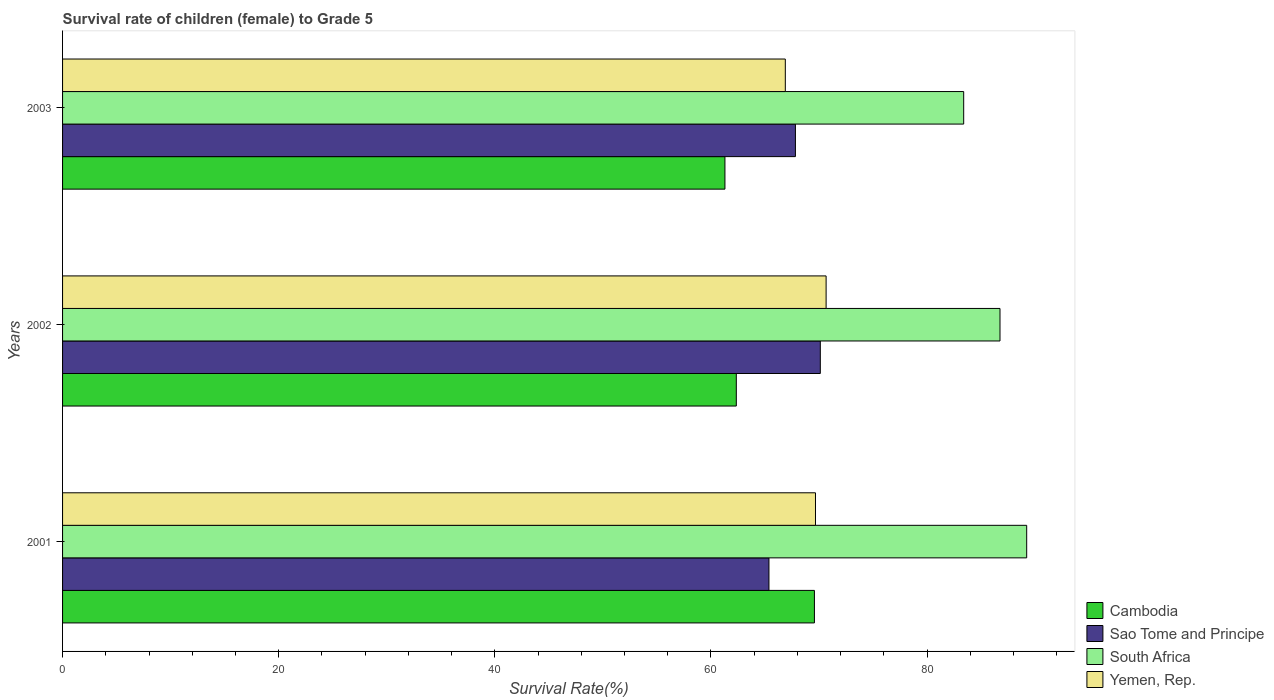How many different coloured bars are there?
Offer a terse response. 4. What is the label of the 1st group of bars from the top?
Provide a short and direct response. 2003. What is the survival rate of female children to grade 5 in Sao Tome and Principe in 2002?
Your answer should be compact. 70.12. Across all years, what is the maximum survival rate of female children to grade 5 in Sao Tome and Principe?
Offer a very short reply. 70.12. Across all years, what is the minimum survival rate of female children to grade 5 in South Africa?
Your response must be concise. 83.39. What is the total survival rate of female children to grade 5 in Sao Tome and Principe in the graph?
Give a very brief answer. 203.31. What is the difference between the survival rate of female children to grade 5 in Sao Tome and Principe in 2001 and that in 2002?
Give a very brief answer. -4.75. What is the difference between the survival rate of female children to grade 5 in South Africa in 2001 and the survival rate of female children to grade 5 in Sao Tome and Principe in 2002?
Your response must be concise. 19.1. What is the average survival rate of female children to grade 5 in Cambodia per year?
Provide a succinct answer. 64.41. In the year 2003, what is the difference between the survival rate of female children to grade 5 in Cambodia and survival rate of female children to grade 5 in Yemen, Rep.?
Ensure brevity in your answer.  -5.59. What is the ratio of the survival rate of female children to grade 5 in Yemen, Rep. in 2001 to that in 2003?
Keep it short and to the point. 1.04. What is the difference between the highest and the second highest survival rate of female children to grade 5 in South Africa?
Ensure brevity in your answer.  2.47. What is the difference between the highest and the lowest survival rate of female children to grade 5 in Yemen, Rep.?
Your answer should be very brief. 3.78. In how many years, is the survival rate of female children to grade 5 in Yemen, Rep. greater than the average survival rate of female children to grade 5 in Yemen, Rep. taken over all years?
Provide a succinct answer. 2. Is it the case that in every year, the sum of the survival rate of female children to grade 5 in Sao Tome and Principe and survival rate of female children to grade 5 in South Africa is greater than the sum of survival rate of female children to grade 5 in Yemen, Rep. and survival rate of female children to grade 5 in Cambodia?
Give a very brief answer. Yes. What does the 3rd bar from the top in 2001 represents?
Keep it short and to the point. Sao Tome and Principe. What does the 2nd bar from the bottom in 2003 represents?
Keep it short and to the point. Sao Tome and Principe. Is it the case that in every year, the sum of the survival rate of female children to grade 5 in Sao Tome and Principe and survival rate of female children to grade 5 in Yemen, Rep. is greater than the survival rate of female children to grade 5 in Cambodia?
Give a very brief answer. Yes. Are all the bars in the graph horizontal?
Offer a terse response. Yes. Are the values on the major ticks of X-axis written in scientific E-notation?
Offer a terse response. No. Does the graph contain grids?
Your answer should be very brief. No. Where does the legend appear in the graph?
Provide a succinct answer. Bottom right. How many legend labels are there?
Offer a terse response. 4. How are the legend labels stacked?
Your response must be concise. Vertical. What is the title of the graph?
Ensure brevity in your answer.  Survival rate of children (female) to Grade 5. Does "Poland" appear as one of the legend labels in the graph?
Provide a short and direct response. No. What is the label or title of the X-axis?
Provide a succinct answer. Survival Rate(%). What is the Survival Rate(%) of Cambodia in 2001?
Your response must be concise. 69.58. What is the Survival Rate(%) of Sao Tome and Principe in 2001?
Keep it short and to the point. 65.37. What is the Survival Rate(%) in South Africa in 2001?
Provide a short and direct response. 89.22. What is the Survival Rate(%) in Yemen, Rep. in 2001?
Your response must be concise. 69.67. What is the Survival Rate(%) in Cambodia in 2002?
Provide a succinct answer. 62.35. What is the Survival Rate(%) of Sao Tome and Principe in 2002?
Your response must be concise. 70.12. What is the Survival Rate(%) in South Africa in 2002?
Offer a very short reply. 86.75. What is the Survival Rate(%) of Yemen, Rep. in 2002?
Offer a very short reply. 70.66. What is the Survival Rate(%) in Cambodia in 2003?
Offer a terse response. 61.29. What is the Survival Rate(%) of Sao Tome and Principe in 2003?
Ensure brevity in your answer.  67.82. What is the Survival Rate(%) of South Africa in 2003?
Give a very brief answer. 83.39. What is the Survival Rate(%) of Yemen, Rep. in 2003?
Your answer should be very brief. 66.88. Across all years, what is the maximum Survival Rate(%) in Cambodia?
Give a very brief answer. 69.58. Across all years, what is the maximum Survival Rate(%) in Sao Tome and Principe?
Make the answer very short. 70.12. Across all years, what is the maximum Survival Rate(%) in South Africa?
Your response must be concise. 89.22. Across all years, what is the maximum Survival Rate(%) in Yemen, Rep.?
Your answer should be compact. 70.66. Across all years, what is the minimum Survival Rate(%) of Cambodia?
Provide a short and direct response. 61.29. Across all years, what is the minimum Survival Rate(%) of Sao Tome and Principe?
Your answer should be very brief. 65.37. Across all years, what is the minimum Survival Rate(%) in South Africa?
Give a very brief answer. 83.39. Across all years, what is the minimum Survival Rate(%) in Yemen, Rep.?
Provide a succinct answer. 66.88. What is the total Survival Rate(%) of Cambodia in the graph?
Your answer should be compact. 193.22. What is the total Survival Rate(%) of Sao Tome and Principe in the graph?
Offer a very short reply. 203.31. What is the total Survival Rate(%) in South Africa in the graph?
Your answer should be very brief. 259.36. What is the total Survival Rate(%) in Yemen, Rep. in the graph?
Give a very brief answer. 207.21. What is the difference between the Survival Rate(%) in Cambodia in 2001 and that in 2002?
Your answer should be compact. 7.23. What is the difference between the Survival Rate(%) in Sao Tome and Principe in 2001 and that in 2002?
Provide a short and direct response. -4.75. What is the difference between the Survival Rate(%) of South Africa in 2001 and that in 2002?
Make the answer very short. 2.47. What is the difference between the Survival Rate(%) in Yemen, Rep. in 2001 and that in 2002?
Keep it short and to the point. -0.98. What is the difference between the Survival Rate(%) in Cambodia in 2001 and that in 2003?
Make the answer very short. 8.28. What is the difference between the Survival Rate(%) in Sao Tome and Principe in 2001 and that in 2003?
Your answer should be very brief. -2.45. What is the difference between the Survival Rate(%) of South Africa in 2001 and that in 2003?
Offer a very short reply. 5.83. What is the difference between the Survival Rate(%) of Yemen, Rep. in 2001 and that in 2003?
Provide a short and direct response. 2.79. What is the difference between the Survival Rate(%) in Cambodia in 2002 and that in 2003?
Keep it short and to the point. 1.05. What is the difference between the Survival Rate(%) in Sao Tome and Principe in 2002 and that in 2003?
Provide a succinct answer. 2.3. What is the difference between the Survival Rate(%) of South Africa in 2002 and that in 2003?
Your answer should be very brief. 3.36. What is the difference between the Survival Rate(%) of Yemen, Rep. in 2002 and that in 2003?
Give a very brief answer. 3.78. What is the difference between the Survival Rate(%) of Cambodia in 2001 and the Survival Rate(%) of Sao Tome and Principe in 2002?
Keep it short and to the point. -0.55. What is the difference between the Survival Rate(%) in Cambodia in 2001 and the Survival Rate(%) in South Africa in 2002?
Offer a terse response. -17.17. What is the difference between the Survival Rate(%) of Cambodia in 2001 and the Survival Rate(%) of Yemen, Rep. in 2002?
Make the answer very short. -1.08. What is the difference between the Survival Rate(%) of Sao Tome and Principe in 2001 and the Survival Rate(%) of South Africa in 2002?
Ensure brevity in your answer.  -21.38. What is the difference between the Survival Rate(%) in Sao Tome and Principe in 2001 and the Survival Rate(%) in Yemen, Rep. in 2002?
Keep it short and to the point. -5.29. What is the difference between the Survival Rate(%) of South Africa in 2001 and the Survival Rate(%) of Yemen, Rep. in 2002?
Offer a terse response. 18.56. What is the difference between the Survival Rate(%) in Cambodia in 2001 and the Survival Rate(%) in Sao Tome and Principe in 2003?
Your answer should be very brief. 1.76. What is the difference between the Survival Rate(%) in Cambodia in 2001 and the Survival Rate(%) in South Africa in 2003?
Offer a terse response. -13.81. What is the difference between the Survival Rate(%) in Cambodia in 2001 and the Survival Rate(%) in Yemen, Rep. in 2003?
Keep it short and to the point. 2.69. What is the difference between the Survival Rate(%) in Sao Tome and Principe in 2001 and the Survival Rate(%) in South Africa in 2003?
Provide a short and direct response. -18.02. What is the difference between the Survival Rate(%) in Sao Tome and Principe in 2001 and the Survival Rate(%) in Yemen, Rep. in 2003?
Make the answer very short. -1.51. What is the difference between the Survival Rate(%) of South Africa in 2001 and the Survival Rate(%) of Yemen, Rep. in 2003?
Offer a terse response. 22.34. What is the difference between the Survival Rate(%) in Cambodia in 2002 and the Survival Rate(%) in Sao Tome and Principe in 2003?
Offer a terse response. -5.47. What is the difference between the Survival Rate(%) in Cambodia in 2002 and the Survival Rate(%) in South Africa in 2003?
Give a very brief answer. -21.04. What is the difference between the Survival Rate(%) of Cambodia in 2002 and the Survival Rate(%) of Yemen, Rep. in 2003?
Your answer should be very brief. -4.53. What is the difference between the Survival Rate(%) in Sao Tome and Principe in 2002 and the Survival Rate(%) in South Africa in 2003?
Offer a very short reply. -13.27. What is the difference between the Survival Rate(%) in Sao Tome and Principe in 2002 and the Survival Rate(%) in Yemen, Rep. in 2003?
Offer a very short reply. 3.24. What is the difference between the Survival Rate(%) in South Africa in 2002 and the Survival Rate(%) in Yemen, Rep. in 2003?
Provide a short and direct response. 19.87. What is the average Survival Rate(%) of Cambodia per year?
Keep it short and to the point. 64.41. What is the average Survival Rate(%) in Sao Tome and Principe per year?
Keep it short and to the point. 67.77. What is the average Survival Rate(%) of South Africa per year?
Your response must be concise. 86.45. What is the average Survival Rate(%) in Yemen, Rep. per year?
Your response must be concise. 69.07. In the year 2001, what is the difference between the Survival Rate(%) of Cambodia and Survival Rate(%) of Sao Tome and Principe?
Provide a succinct answer. 4.21. In the year 2001, what is the difference between the Survival Rate(%) of Cambodia and Survival Rate(%) of South Africa?
Give a very brief answer. -19.64. In the year 2001, what is the difference between the Survival Rate(%) in Cambodia and Survival Rate(%) in Yemen, Rep.?
Keep it short and to the point. -0.1. In the year 2001, what is the difference between the Survival Rate(%) in Sao Tome and Principe and Survival Rate(%) in South Africa?
Give a very brief answer. -23.85. In the year 2001, what is the difference between the Survival Rate(%) in Sao Tome and Principe and Survival Rate(%) in Yemen, Rep.?
Keep it short and to the point. -4.31. In the year 2001, what is the difference between the Survival Rate(%) in South Africa and Survival Rate(%) in Yemen, Rep.?
Make the answer very short. 19.55. In the year 2002, what is the difference between the Survival Rate(%) of Cambodia and Survival Rate(%) of Sao Tome and Principe?
Offer a terse response. -7.77. In the year 2002, what is the difference between the Survival Rate(%) of Cambodia and Survival Rate(%) of South Africa?
Ensure brevity in your answer.  -24.4. In the year 2002, what is the difference between the Survival Rate(%) in Cambodia and Survival Rate(%) in Yemen, Rep.?
Provide a short and direct response. -8.31. In the year 2002, what is the difference between the Survival Rate(%) of Sao Tome and Principe and Survival Rate(%) of South Africa?
Your answer should be compact. -16.63. In the year 2002, what is the difference between the Survival Rate(%) in Sao Tome and Principe and Survival Rate(%) in Yemen, Rep.?
Make the answer very short. -0.54. In the year 2002, what is the difference between the Survival Rate(%) in South Africa and Survival Rate(%) in Yemen, Rep.?
Your answer should be very brief. 16.09. In the year 2003, what is the difference between the Survival Rate(%) of Cambodia and Survival Rate(%) of Sao Tome and Principe?
Give a very brief answer. -6.52. In the year 2003, what is the difference between the Survival Rate(%) of Cambodia and Survival Rate(%) of South Africa?
Make the answer very short. -22.09. In the year 2003, what is the difference between the Survival Rate(%) of Cambodia and Survival Rate(%) of Yemen, Rep.?
Your response must be concise. -5.59. In the year 2003, what is the difference between the Survival Rate(%) of Sao Tome and Principe and Survival Rate(%) of South Africa?
Provide a short and direct response. -15.57. In the year 2003, what is the difference between the Survival Rate(%) in Sao Tome and Principe and Survival Rate(%) in Yemen, Rep.?
Offer a very short reply. 0.94. In the year 2003, what is the difference between the Survival Rate(%) in South Africa and Survival Rate(%) in Yemen, Rep.?
Make the answer very short. 16.51. What is the ratio of the Survival Rate(%) in Cambodia in 2001 to that in 2002?
Provide a succinct answer. 1.12. What is the ratio of the Survival Rate(%) of Sao Tome and Principe in 2001 to that in 2002?
Ensure brevity in your answer.  0.93. What is the ratio of the Survival Rate(%) in South Africa in 2001 to that in 2002?
Ensure brevity in your answer.  1.03. What is the ratio of the Survival Rate(%) in Yemen, Rep. in 2001 to that in 2002?
Provide a short and direct response. 0.99. What is the ratio of the Survival Rate(%) of Cambodia in 2001 to that in 2003?
Make the answer very short. 1.14. What is the ratio of the Survival Rate(%) of Sao Tome and Principe in 2001 to that in 2003?
Ensure brevity in your answer.  0.96. What is the ratio of the Survival Rate(%) in South Africa in 2001 to that in 2003?
Your answer should be compact. 1.07. What is the ratio of the Survival Rate(%) of Yemen, Rep. in 2001 to that in 2003?
Your response must be concise. 1.04. What is the ratio of the Survival Rate(%) of Cambodia in 2002 to that in 2003?
Provide a succinct answer. 1.02. What is the ratio of the Survival Rate(%) in Sao Tome and Principe in 2002 to that in 2003?
Make the answer very short. 1.03. What is the ratio of the Survival Rate(%) in South Africa in 2002 to that in 2003?
Offer a terse response. 1.04. What is the ratio of the Survival Rate(%) of Yemen, Rep. in 2002 to that in 2003?
Provide a short and direct response. 1.06. What is the difference between the highest and the second highest Survival Rate(%) in Cambodia?
Provide a succinct answer. 7.23. What is the difference between the highest and the second highest Survival Rate(%) in Sao Tome and Principe?
Your response must be concise. 2.3. What is the difference between the highest and the second highest Survival Rate(%) in South Africa?
Offer a terse response. 2.47. What is the difference between the highest and the second highest Survival Rate(%) of Yemen, Rep.?
Keep it short and to the point. 0.98. What is the difference between the highest and the lowest Survival Rate(%) in Cambodia?
Keep it short and to the point. 8.28. What is the difference between the highest and the lowest Survival Rate(%) in Sao Tome and Principe?
Keep it short and to the point. 4.75. What is the difference between the highest and the lowest Survival Rate(%) of South Africa?
Provide a succinct answer. 5.83. What is the difference between the highest and the lowest Survival Rate(%) in Yemen, Rep.?
Make the answer very short. 3.78. 